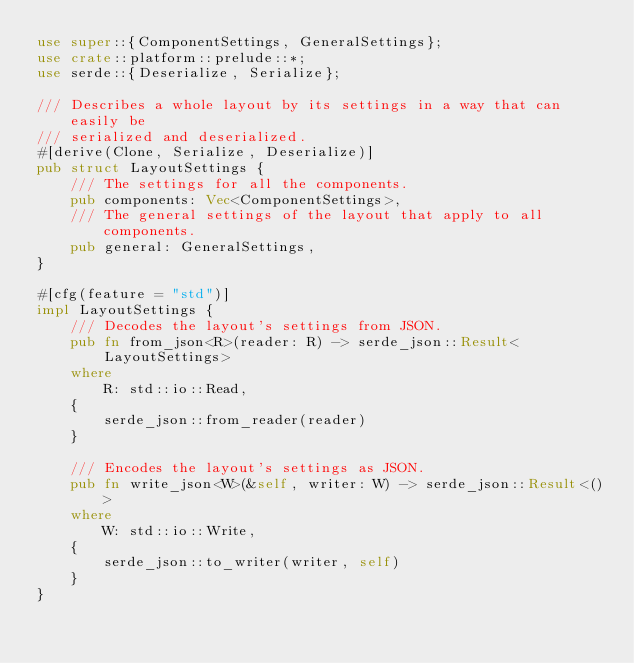<code> <loc_0><loc_0><loc_500><loc_500><_Rust_>use super::{ComponentSettings, GeneralSettings};
use crate::platform::prelude::*;
use serde::{Deserialize, Serialize};

/// Describes a whole layout by its settings in a way that can easily be
/// serialized and deserialized.
#[derive(Clone, Serialize, Deserialize)]
pub struct LayoutSettings {
    /// The settings for all the components.
    pub components: Vec<ComponentSettings>,
    /// The general settings of the layout that apply to all components.
    pub general: GeneralSettings,
}

#[cfg(feature = "std")]
impl LayoutSettings {
    /// Decodes the layout's settings from JSON.
    pub fn from_json<R>(reader: R) -> serde_json::Result<LayoutSettings>
    where
        R: std::io::Read,
    {
        serde_json::from_reader(reader)
    }

    /// Encodes the layout's settings as JSON.
    pub fn write_json<W>(&self, writer: W) -> serde_json::Result<()>
    where
        W: std::io::Write,
    {
        serde_json::to_writer(writer, self)
    }
}
</code> 